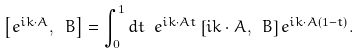<formula> <loc_0><loc_0><loc_500><loc_500>\left [ e ^ { i k \cdot A } , \ B \right ] = \int _ { 0 } ^ { 1 } d t \ e ^ { i k \cdot A t } \left [ i k \cdot A , \ B \right ] e ^ { i k \cdot A ( 1 - t ) } .</formula> 